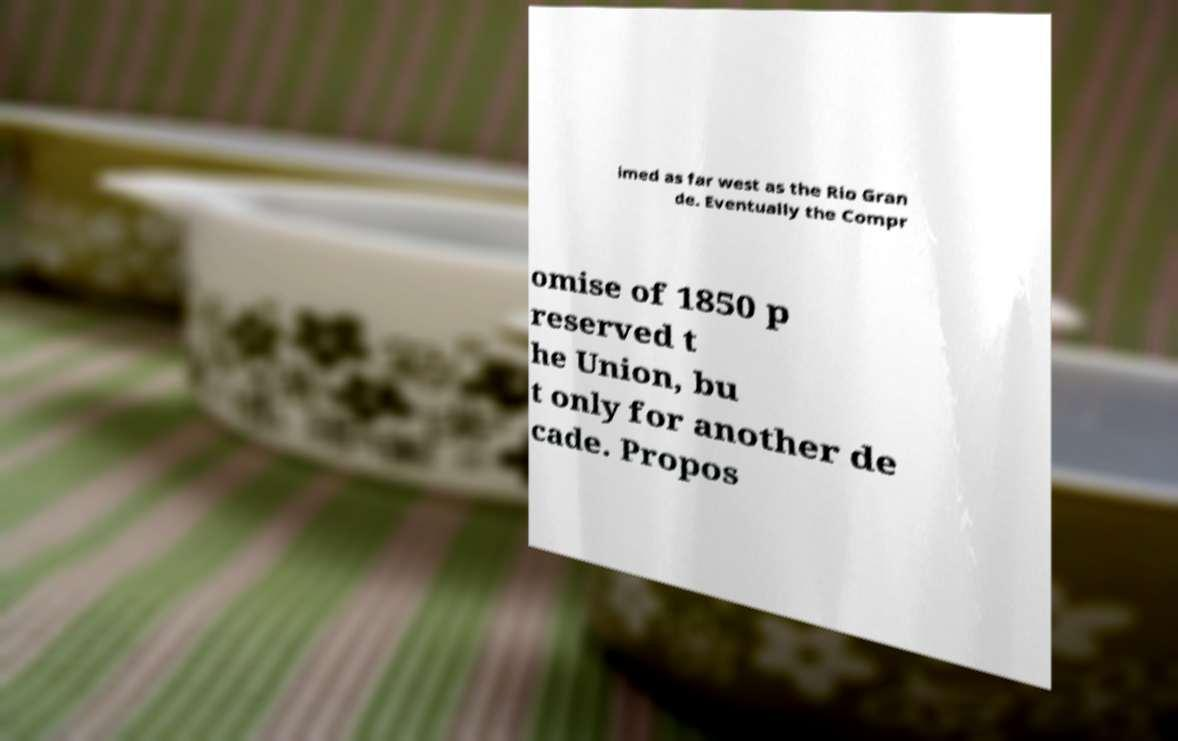There's text embedded in this image that I need extracted. Can you transcribe it verbatim? imed as far west as the Rio Gran de. Eventually the Compr omise of 1850 p reserved t he Union, bu t only for another de cade. Propos 